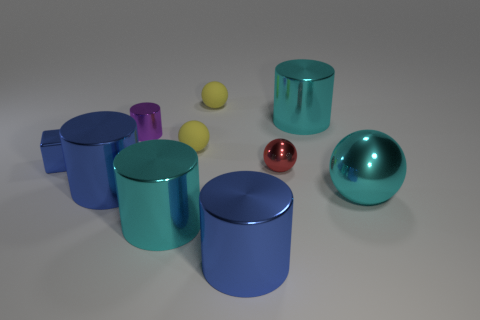Subtract 1 spheres. How many spheres are left? 3 Subtract all purple cylinders. How many cylinders are left? 4 Subtract all purple shiny cylinders. How many cylinders are left? 4 Subtract all green cylinders. Subtract all blue spheres. How many cylinders are left? 5 Subtract all spheres. How many objects are left? 6 Add 1 tiny red objects. How many tiny red objects are left? 2 Add 5 small cyan matte cylinders. How many small cyan matte cylinders exist? 5 Subtract 0 red cylinders. How many objects are left? 10 Subtract all large purple matte objects. Subtract all small matte spheres. How many objects are left? 8 